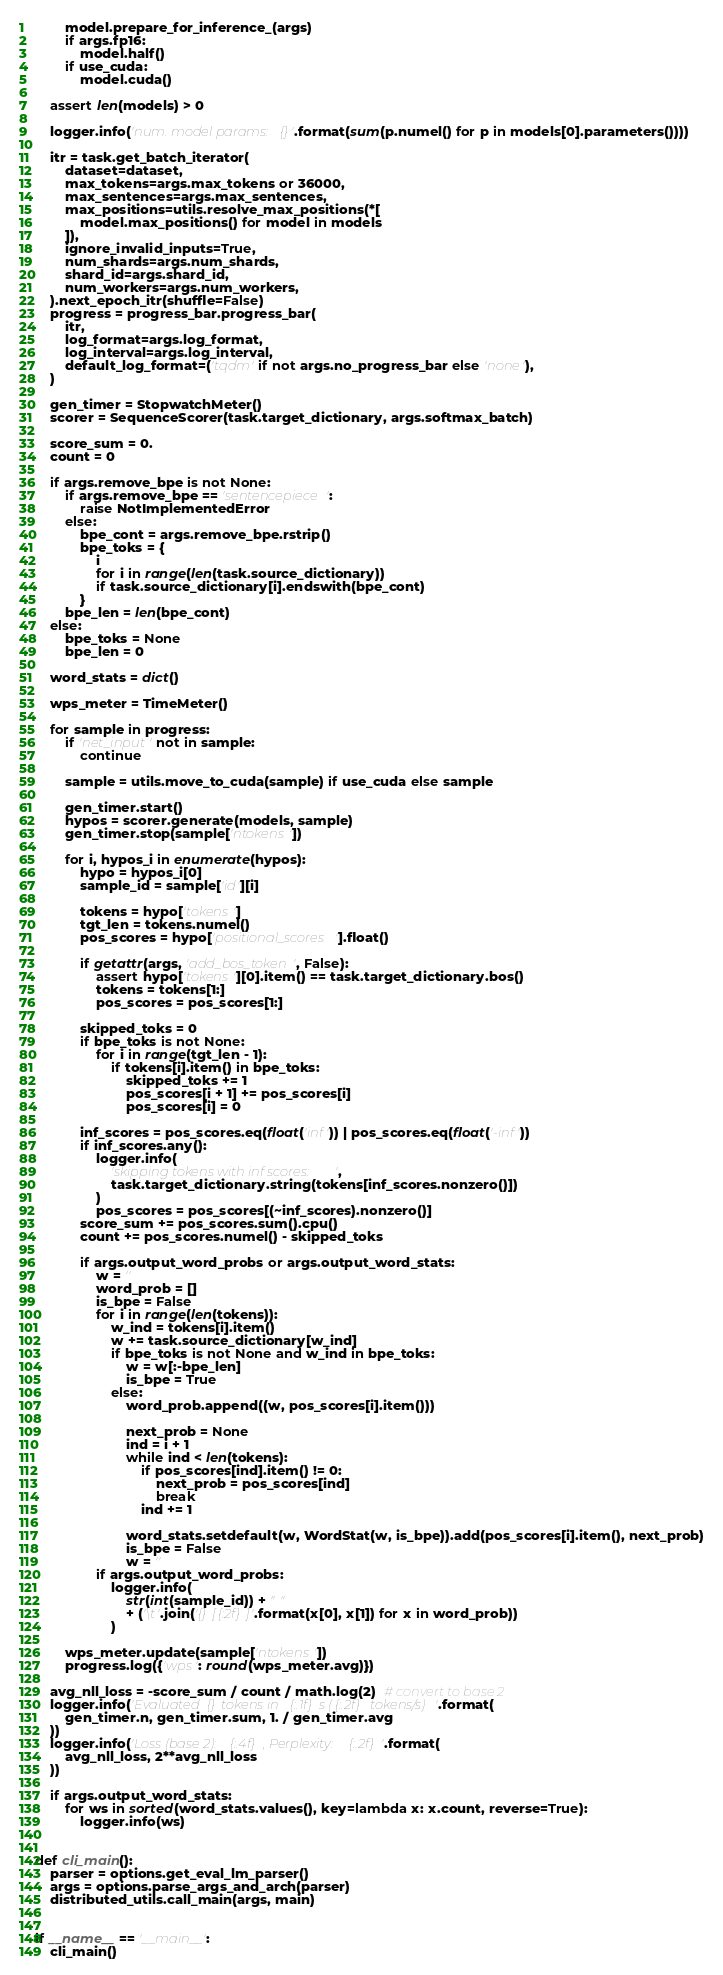Convert code to text. <code><loc_0><loc_0><loc_500><loc_500><_Python_>        model.prepare_for_inference_(args)
        if args.fp16:
            model.half()
        if use_cuda:
            model.cuda()

    assert len(models) > 0

    logger.info('num. model params: {}'.format(sum(p.numel() for p in models[0].parameters())))

    itr = task.get_batch_iterator(
        dataset=dataset,
        max_tokens=args.max_tokens or 36000,
        max_sentences=args.max_sentences,
        max_positions=utils.resolve_max_positions(*[
            model.max_positions() for model in models
        ]),
        ignore_invalid_inputs=True,
        num_shards=args.num_shards,
        shard_id=args.shard_id,
        num_workers=args.num_workers,
    ).next_epoch_itr(shuffle=False)
    progress = progress_bar.progress_bar(
        itr,
        log_format=args.log_format,
        log_interval=args.log_interval,
        default_log_format=('tqdm' if not args.no_progress_bar else 'none'),
    )

    gen_timer = StopwatchMeter()
    scorer = SequenceScorer(task.target_dictionary, args.softmax_batch)

    score_sum = 0.
    count = 0

    if args.remove_bpe is not None:
        if args.remove_bpe == 'sentencepiece':
            raise NotImplementedError
        else:
            bpe_cont = args.remove_bpe.rstrip()
            bpe_toks = {
                i
                for i in range(len(task.source_dictionary))
                if task.source_dictionary[i].endswith(bpe_cont)
            }
        bpe_len = len(bpe_cont)
    else:
        bpe_toks = None
        bpe_len = 0

    word_stats = dict()

    wps_meter = TimeMeter()

    for sample in progress:
        if 'net_input' not in sample:
            continue

        sample = utils.move_to_cuda(sample) if use_cuda else sample

        gen_timer.start()
        hypos = scorer.generate(models, sample)
        gen_timer.stop(sample['ntokens'])

        for i, hypos_i in enumerate(hypos):
            hypo = hypos_i[0]
            sample_id = sample['id'][i]

            tokens = hypo['tokens']
            tgt_len = tokens.numel()
            pos_scores = hypo['positional_scores'].float()

            if getattr(args, 'add_bos_token', False):
                assert hypo['tokens'][0].item() == task.target_dictionary.bos()
                tokens = tokens[1:]
                pos_scores = pos_scores[1:]

            skipped_toks = 0
            if bpe_toks is not None:
                for i in range(tgt_len - 1):
                    if tokens[i].item() in bpe_toks:
                        skipped_toks += 1
                        pos_scores[i + 1] += pos_scores[i]
                        pos_scores[i] = 0

            inf_scores = pos_scores.eq(float('inf')) | pos_scores.eq(float('-inf'))
            if inf_scores.any():
                logger.info(
                    'skipping tokens with inf scores:',
                    task.target_dictionary.string(tokens[inf_scores.nonzero()])
                )
                pos_scores = pos_scores[(~inf_scores).nonzero()]
            score_sum += pos_scores.sum().cpu()
            count += pos_scores.numel() - skipped_toks

            if args.output_word_probs or args.output_word_stats:
                w = ''
                word_prob = []
                is_bpe = False
                for i in range(len(tokens)):
                    w_ind = tokens[i].item()
                    w += task.source_dictionary[w_ind]
                    if bpe_toks is not None and w_ind in bpe_toks:
                        w = w[:-bpe_len]
                        is_bpe = True
                    else:
                        word_prob.append((w, pos_scores[i].item()))

                        next_prob = None
                        ind = i + 1
                        while ind < len(tokens):
                            if pos_scores[ind].item() != 0:
                                next_prob = pos_scores[ind]
                                break
                            ind += 1

                        word_stats.setdefault(w, WordStat(w, is_bpe)).add(pos_scores[i].item(), next_prob)
                        is_bpe = False
                        w = ''
                if args.output_word_probs:
                    logger.info(
                        str(int(sample_id)) + " "
                        + ('\t'.join('{} [{:2f}]'.format(x[0], x[1]) for x in word_prob))
                    )

        wps_meter.update(sample['ntokens'])
        progress.log({'wps': round(wps_meter.avg)})

    avg_nll_loss = -score_sum / count / math.log(2)  # convert to base 2
    logger.info('Evaluated {} tokens in {:.1f}s ({:.2f} tokens/s)'.format(
        gen_timer.n, gen_timer.sum, 1. / gen_timer.avg
    ))
    logger.info('Loss (base 2): {:.4f}, Perplexity: {:.2f}'.format(
        avg_nll_loss, 2**avg_nll_loss
    ))

    if args.output_word_stats:
        for ws in sorted(word_stats.values(), key=lambda x: x.count, reverse=True):
            logger.info(ws)


def cli_main():
    parser = options.get_eval_lm_parser()
    args = options.parse_args_and_arch(parser)
    distributed_utils.call_main(args, main)


if __name__ == '__main__':
    cli_main()
</code> 